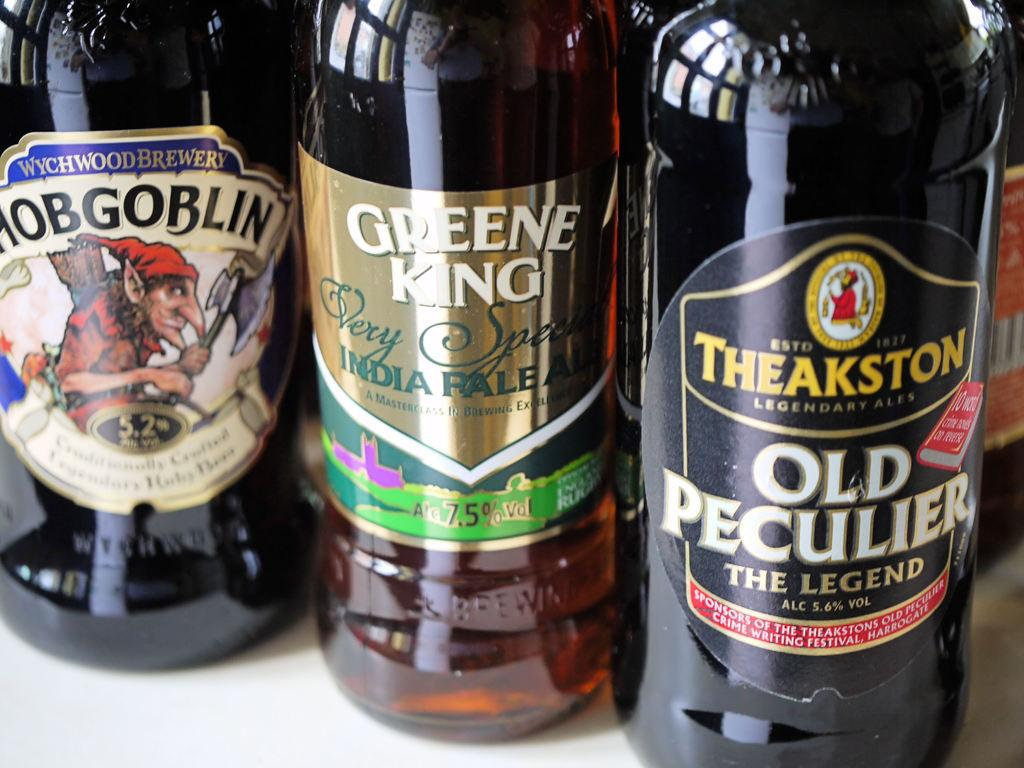<image>
Share a concise interpretation of the image provided. Hobgoblin, Greene King, Old Peculier the legend brown bottles. 